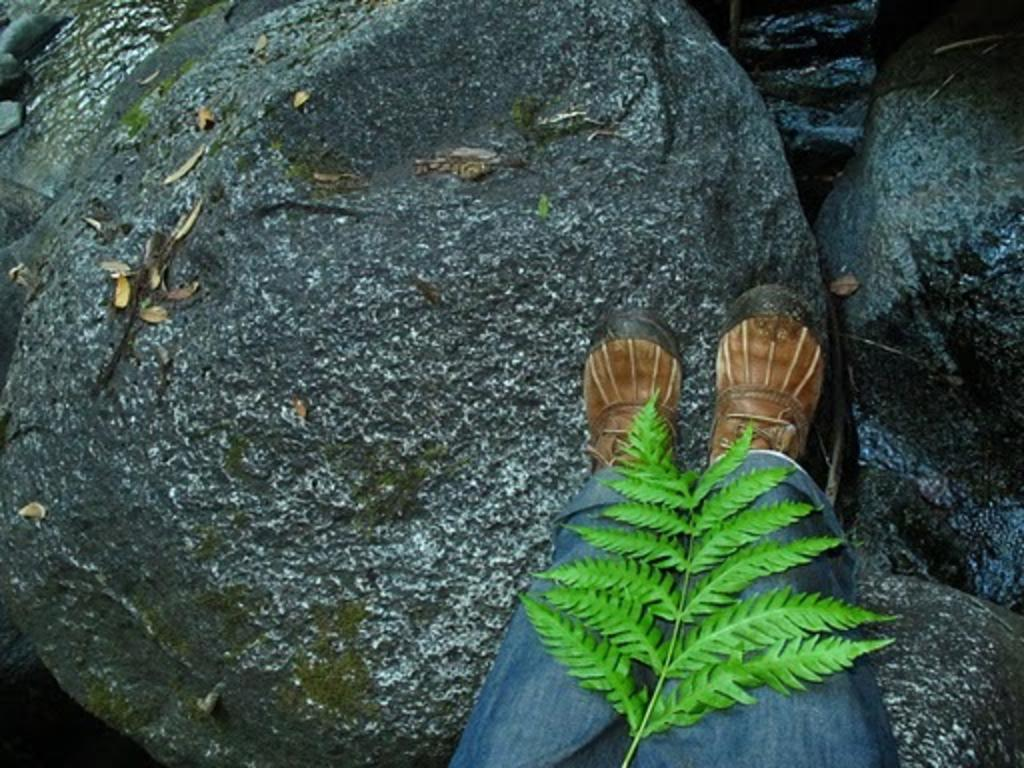What is visible at the bottom of the image? There are two legs of a person in the image. What is unique about the legs in the image? The legs have leaves on a stem. What can be seen in the background of the image? There is a group of rocks in the background of the image. What type of celery is being used to express fear in the image? There is no celery present in the image, and no expression of fear can be observed. 